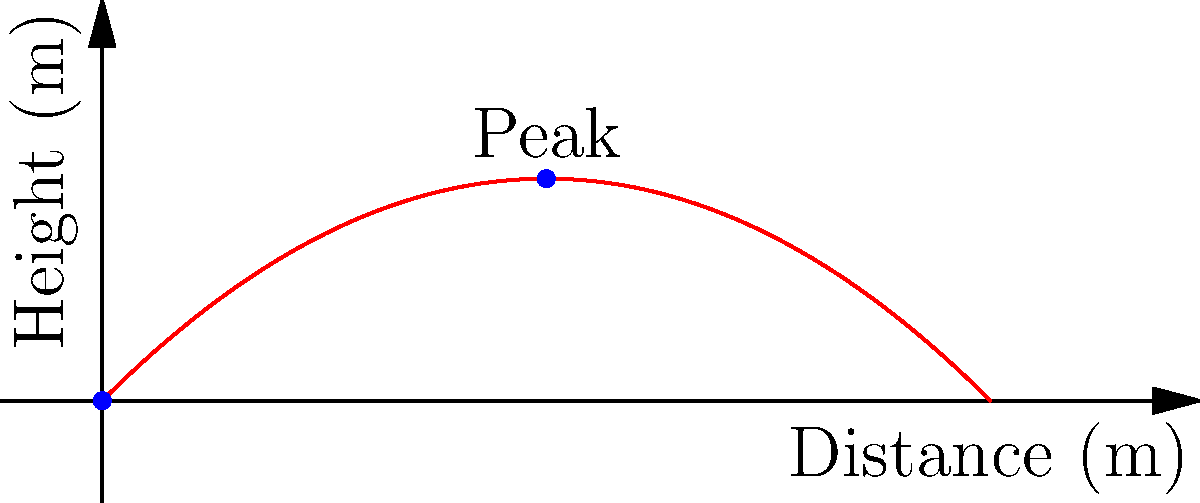In a sociological experiment studying the impact of environmental factors on voting behavior, researchers use a projectile motion demonstration. A projectile is launched with an initial velocity of 30 m/s at a 45-degree angle. Assuming the launch point is at ground level (0,0), what is the maximum height reached by the projectile? How might this physical concept relate to the trajectory of societal influence on voter behavior? Let's approach this step-by-step:

1) For a projectile launched at an angle θ with initial velocity v₀, the maximum height h_max is given by:

   $$ h_{max} = \frac{(v_0 \sin \theta)^2}{2g} $$

   where g is the acceleration due to gravity (9.8 m/s²).

2) We're given:
   - Initial velocity v₀ = 30 m/s
   - Launch angle θ = 45°
   - g = 9.8 m/s²

3) First, let's calculate sin(45°):
   $$ \sin 45° = \frac{\sqrt{2}}{2} \approx 0.707 $$

4) Now, let's substitute these values into our equation:

   $$ h_{max} = \frac{(30 \cdot 0.707)^2}{2 \cdot 9.8} $$

5) Simplify:
   $$ h_{max} = \frac{449.82}{19.6} \approx 22.95 \text{ m} $$

Relating to sociology: Just as the projectile reaches its peak before descending, societal influences on voter behavior may also have peak effects before waning. The parabolic trajectory could represent how societal factors build up, reach a maximum impact, and then potentially decrease in influence as election day approaches.
Answer: 22.95 meters 